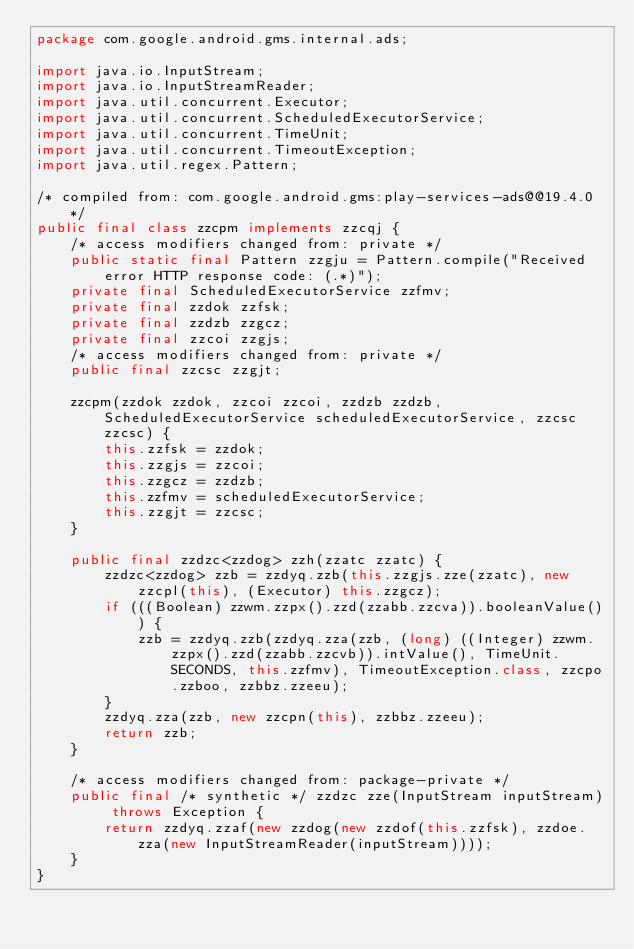Convert code to text. <code><loc_0><loc_0><loc_500><loc_500><_Java_>package com.google.android.gms.internal.ads;

import java.io.InputStream;
import java.io.InputStreamReader;
import java.util.concurrent.Executor;
import java.util.concurrent.ScheduledExecutorService;
import java.util.concurrent.TimeUnit;
import java.util.concurrent.TimeoutException;
import java.util.regex.Pattern;

/* compiled from: com.google.android.gms:play-services-ads@@19.4.0 */
public final class zzcpm implements zzcqj {
    /* access modifiers changed from: private */
    public static final Pattern zzgju = Pattern.compile("Received error HTTP response code: (.*)");
    private final ScheduledExecutorService zzfmv;
    private final zzdok zzfsk;
    private final zzdzb zzgcz;
    private final zzcoi zzgjs;
    /* access modifiers changed from: private */
    public final zzcsc zzgjt;

    zzcpm(zzdok zzdok, zzcoi zzcoi, zzdzb zzdzb, ScheduledExecutorService scheduledExecutorService, zzcsc zzcsc) {
        this.zzfsk = zzdok;
        this.zzgjs = zzcoi;
        this.zzgcz = zzdzb;
        this.zzfmv = scheduledExecutorService;
        this.zzgjt = zzcsc;
    }

    public final zzdzc<zzdog> zzh(zzatc zzatc) {
        zzdzc<zzdog> zzb = zzdyq.zzb(this.zzgjs.zze(zzatc), new zzcpl(this), (Executor) this.zzgcz);
        if (((Boolean) zzwm.zzpx().zzd(zzabb.zzcva)).booleanValue()) {
            zzb = zzdyq.zzb(zzdyq.zza(zzb, (long) ((Integer) zzwm.zzpx().zzd(zzabb.zzcvb)).intValue(), TimeUnit.SECONDS, this.zzfmv), TimeoutException.class, zzcpo.zzboo, zzbbz.zzeeu);
        }
        zzdyq.zza(zzb, new zzcpn(this), zzbbz.zzeeu);
        return zzb;
    }

    /* access modifiers changed from: package-private */
    public final /* synthetic */ zzdzc zze(InputStream inputStream) throws Exception {
        return zzdyq.zzaf(new zzdog(new zzdof(this.zzfsk), zzdoe.zza(new InputStreamReader(inputStream))));
    }
}
</code> 